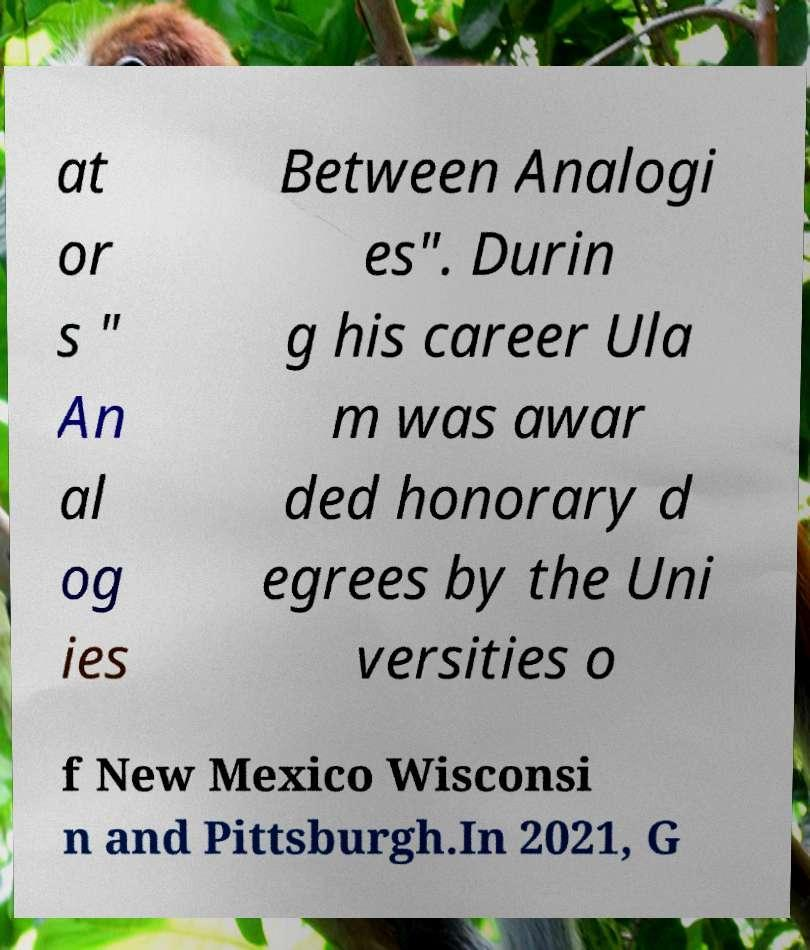There's text embedded in this image that I need extracted. Can you transcribe it verbatim? at or s " An al og ies Between Analogi es". Durin g his career Ula m was awar ded honorary d egrees by the Uni versities o f New Mexico Wisconsi n and Pittsburgh.In 2021, G 